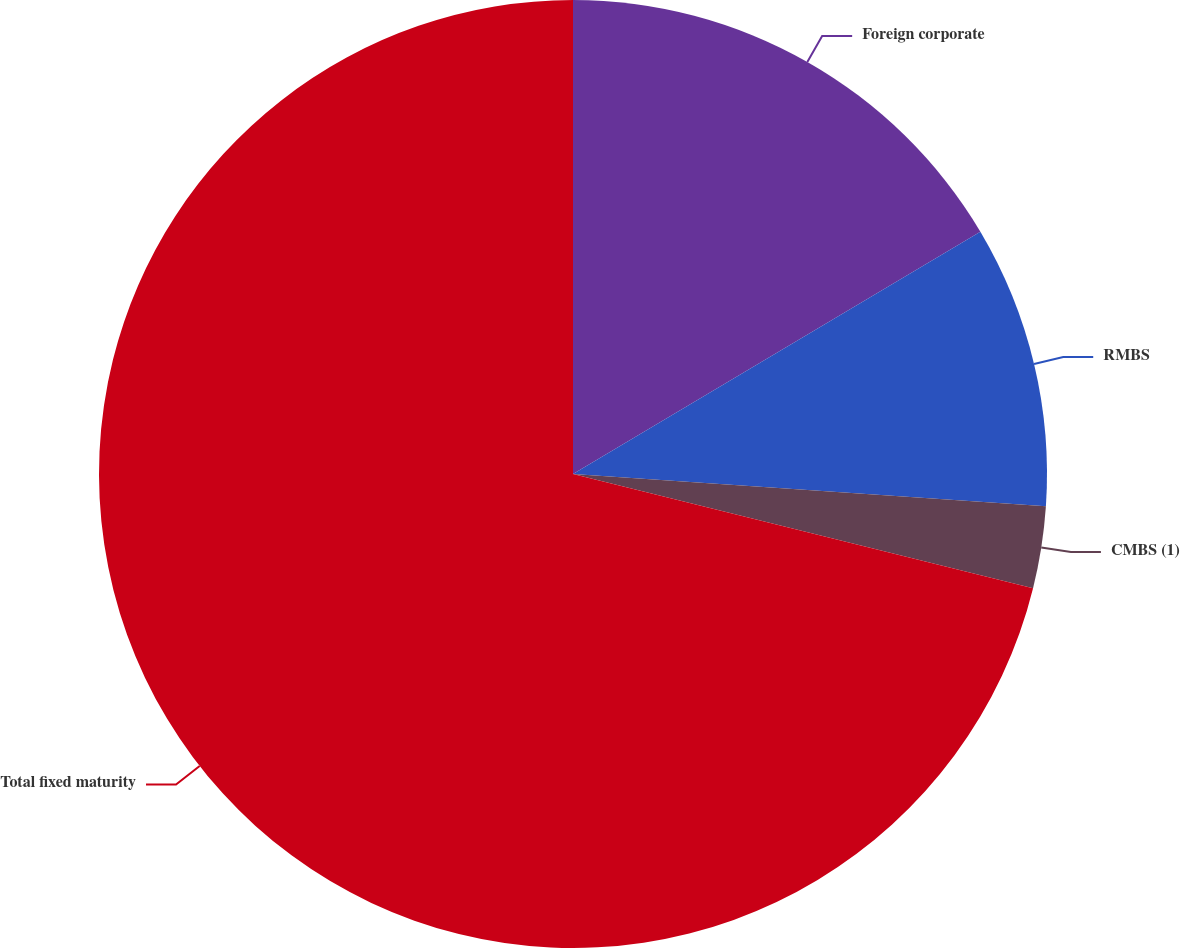Convert chart to OTSL. <chart><loc_0><loc_0><loc_500><loc_500><pie_chart><fcel>Foreign corporate<fcel>RMBS<fcel>CMBS (1)<fcel>Total fixed maturity<nl><fcel>16.46%<fcel>9.62%<fcel>2.79%<fcel>71.13%<nl></chart> 